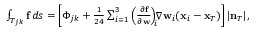Convert formula to latex. <formula><loc_0><loc_0><loc_500><loc_500>\begin{array} { r } { \int _ { T _ { j k } } { f } \, d s = \left [ \Phi _ { j k } + \frac { 1 } { 2 4 } \sum _ { i = 1 } ^ { 3 } \left ( \frac { \partial { f } } { \partial { w } } \right ) _ { \, i } \, \nabla { w } _ { i } ( { x } _ { i } - { x } _ { T } ) \right ] | { n } _ { T } | , } \end{array}</formula> 